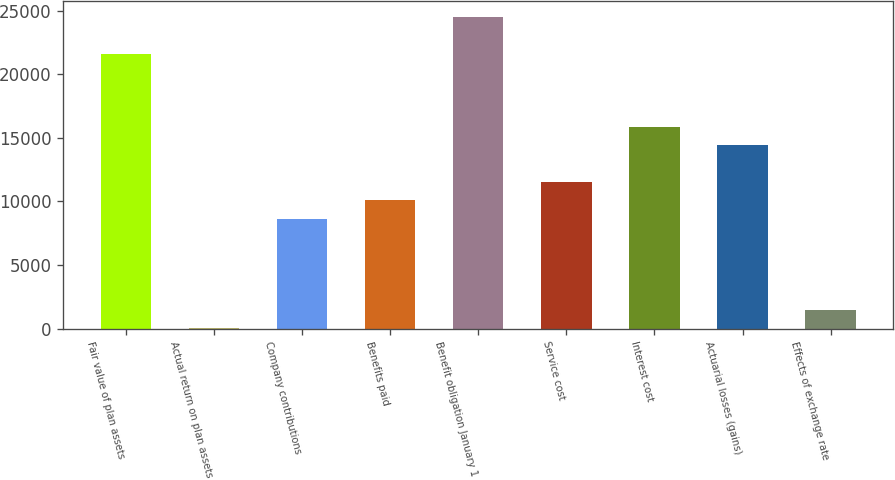Convert chart to OTSL. <chart><loc_0><loc_0><loc_500><loc_500><bar_chart><fcel>Fair value of plan assets<fcel>Actual return on plan assets<fcel>Company contributions<fcel>Benefits paid<fcel>Benefit obligation January 1<fcel>Service cost<fcel>Interest cost<fcel>Actuarial losses (gains)<fcel>Effects of exchange rate<nl><fcel>21621<fcel>6<fcel>8652<fcel>10093<fcel>24503<fcel>11534<fcel>15857<fcel>14416<fcel>1447<nl></chart> 